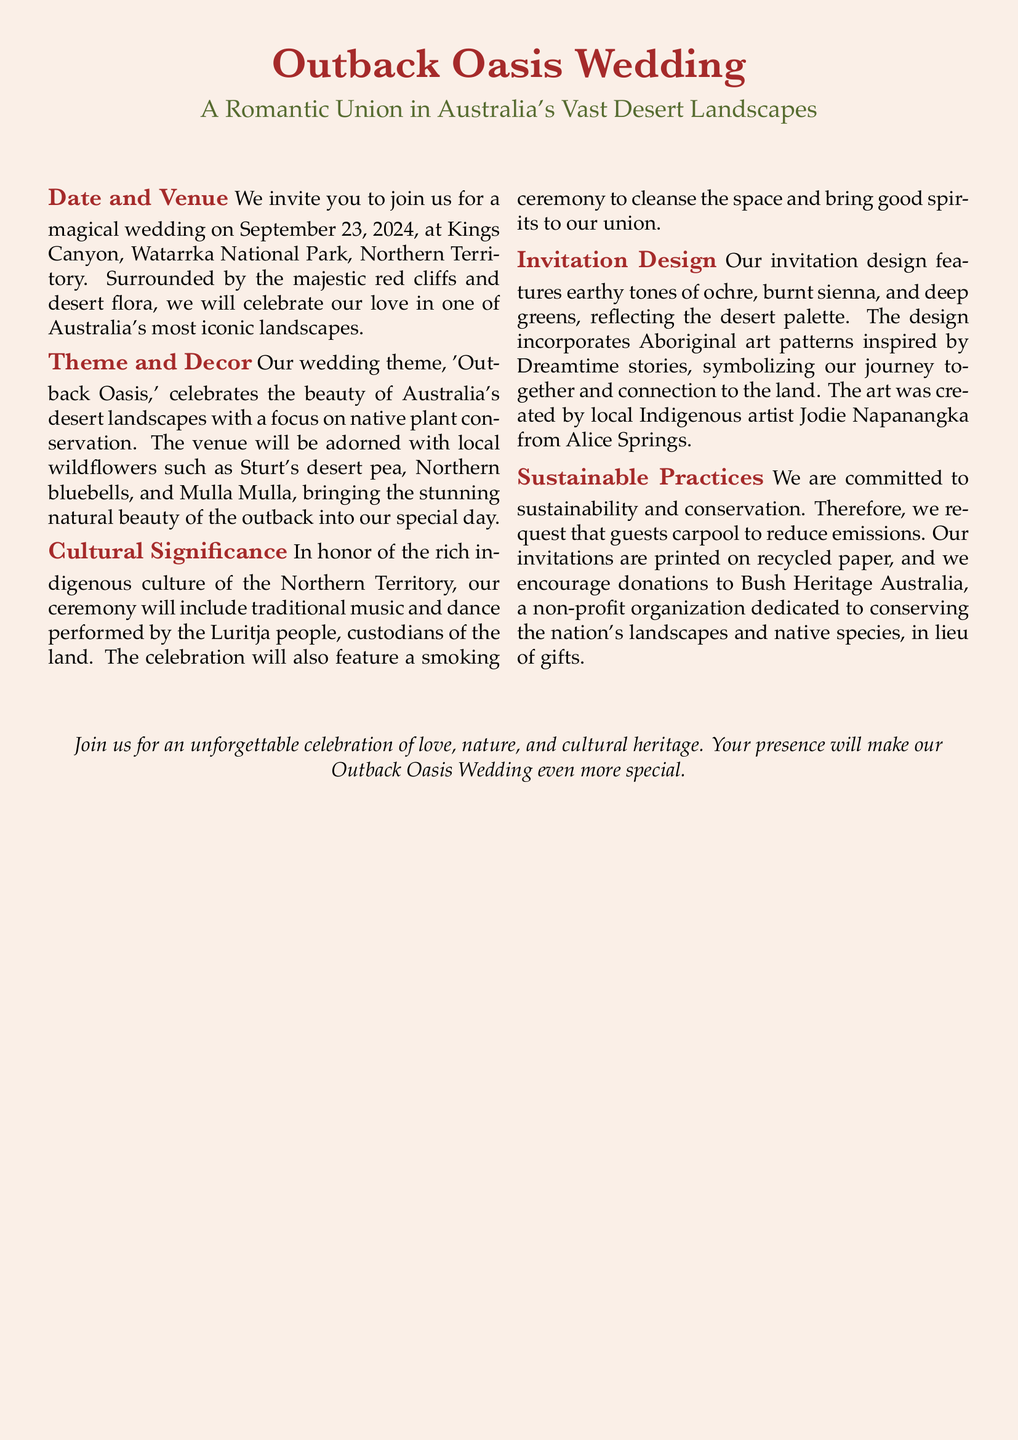What is the wedding date? The document specifies the wedding date as September 23, 2024.
Answer: September 23, 2024 Where will the wedding take place? The venue is Kings Canyon, Watarrka National Park, Northern Territory.
Answer: Kings Canyon, Watarrka National Park, Northern Territory What is the wedding theme? The theme is 'Outback Oasis,' which celebrates desert landscapes and native plant conservation.
Answer: Outback Oasis Who will perform traditional music and dance at the ceremony? The performance will be by the Luritja people, custodians of the land.
Answer: Luritja people What kind of ceremony will be included? A smoking ceremony will be part of the celebrations to cleanse the space.
Answer: Smoking ceremony What colors are featured in the invitation design? The design highlights earthy tones of ochre, burnt sienna, and deep greens.
Answer: Ochre, burnt sienna, deep greens What organization do the couple encourage donations to? They encourage guests to donate to Bush Heritage Australia.
Answer: Bush Heritage Australia What type of paper is used for the invitations? The invitations are printed on recycled paper.
Answer: Recycled paper How are guests encouraged to reduce emissions? Guests are requested to carpool to the wedding venue.
Answer: Carpool 